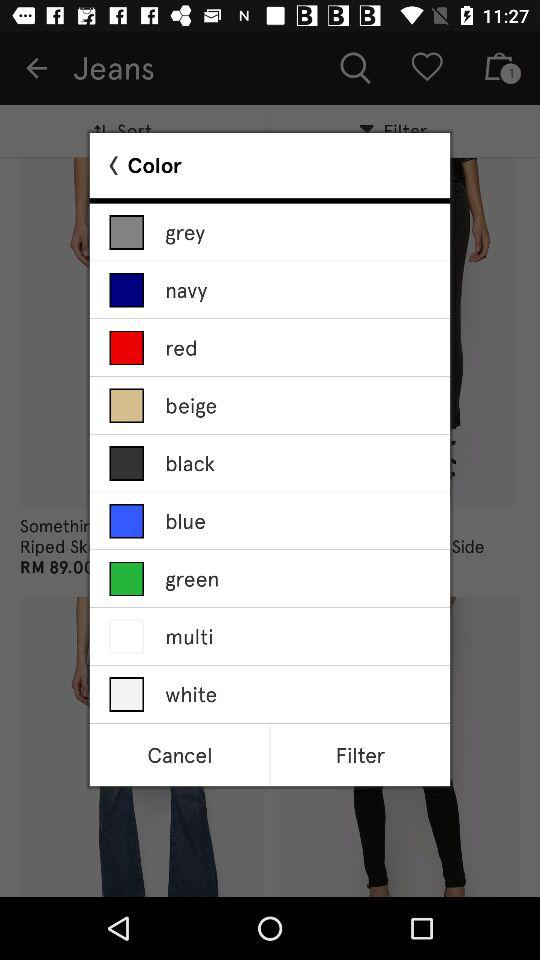How many color options are there?
Answer the question using a single word or phrase. 9 